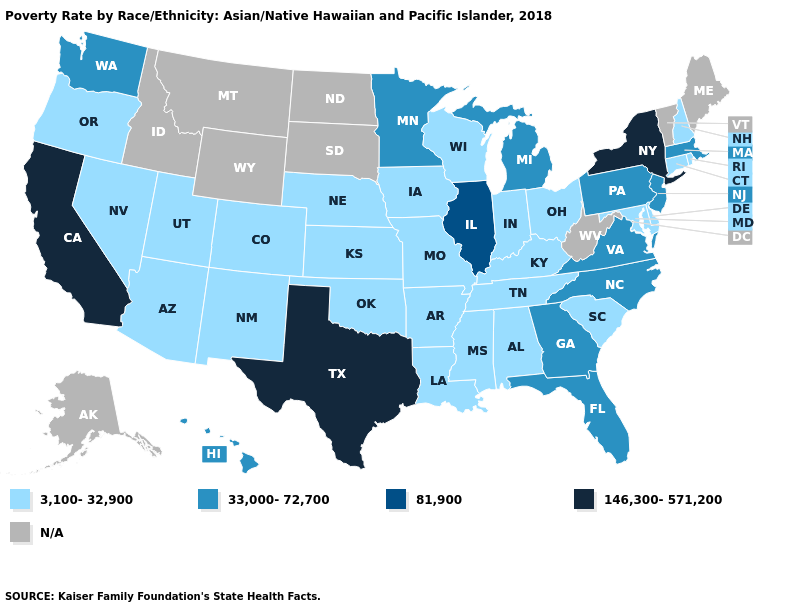What is the highest value in the South ?
Answer briefly. 146,300-571,200. Does the map have missing data?
Write a very short answer. Yes. Name the states that have a value in the range N/A?
Be succinct. Alaska, Idaho, Maine, Montana, North Dakota, South Dakota, Vermont, West Virginia, Wyoming. What is the highest value in the MidWest ?
Concise answer only. 81,900. What is the value of Florida?
Write a very short answer. 33,000-72,700. Does the first symbol in the legend represent the smallest category?
Give a very brief answer. Yes. Does Florida have the lowest value in the USA?
Keep it brief. No. What is the value of Georgia?
Answer briefly. 33,000-72,700. Among the states that border Pennsylvania , does New Jersey have the lowest value?
Short answer required. No. Does California have the lowest value in the USA?
Concise answer only. No. Does North Carolina have the highest value in the USA?
Concise answer only. No. Which states have the highest value in the USA?
Short answer required. California, New York, Texas. Is the legend a continuous bar?
Keep it brief. No. 